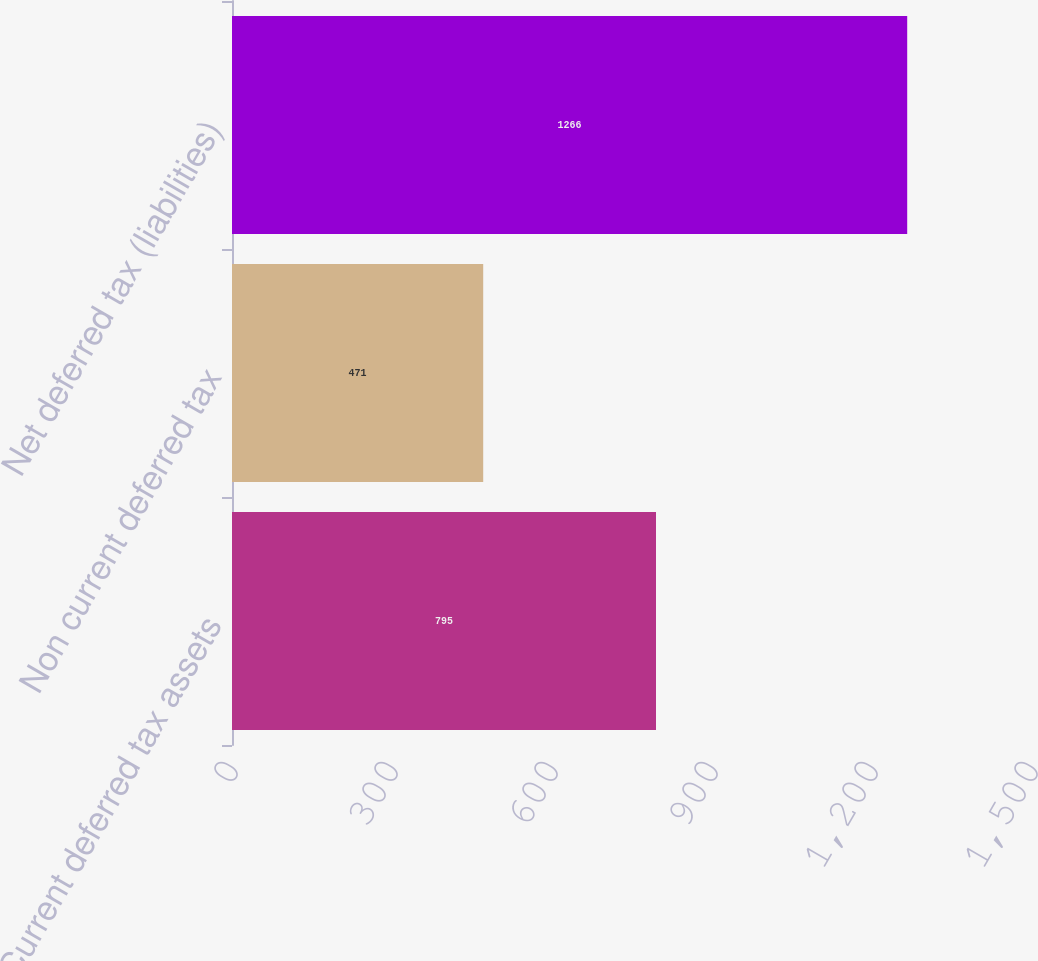Convert chart to OTSL. <chart><loc_0><loc_0><loc_500><loc_500><bar_chart><fcel>Current deferred tax assets<fcel>Non current deferred tax<fcel>Net deferred tax (liabilities)<nl><fcel>795<fcel>471<fcel>1266<nl></chart> 